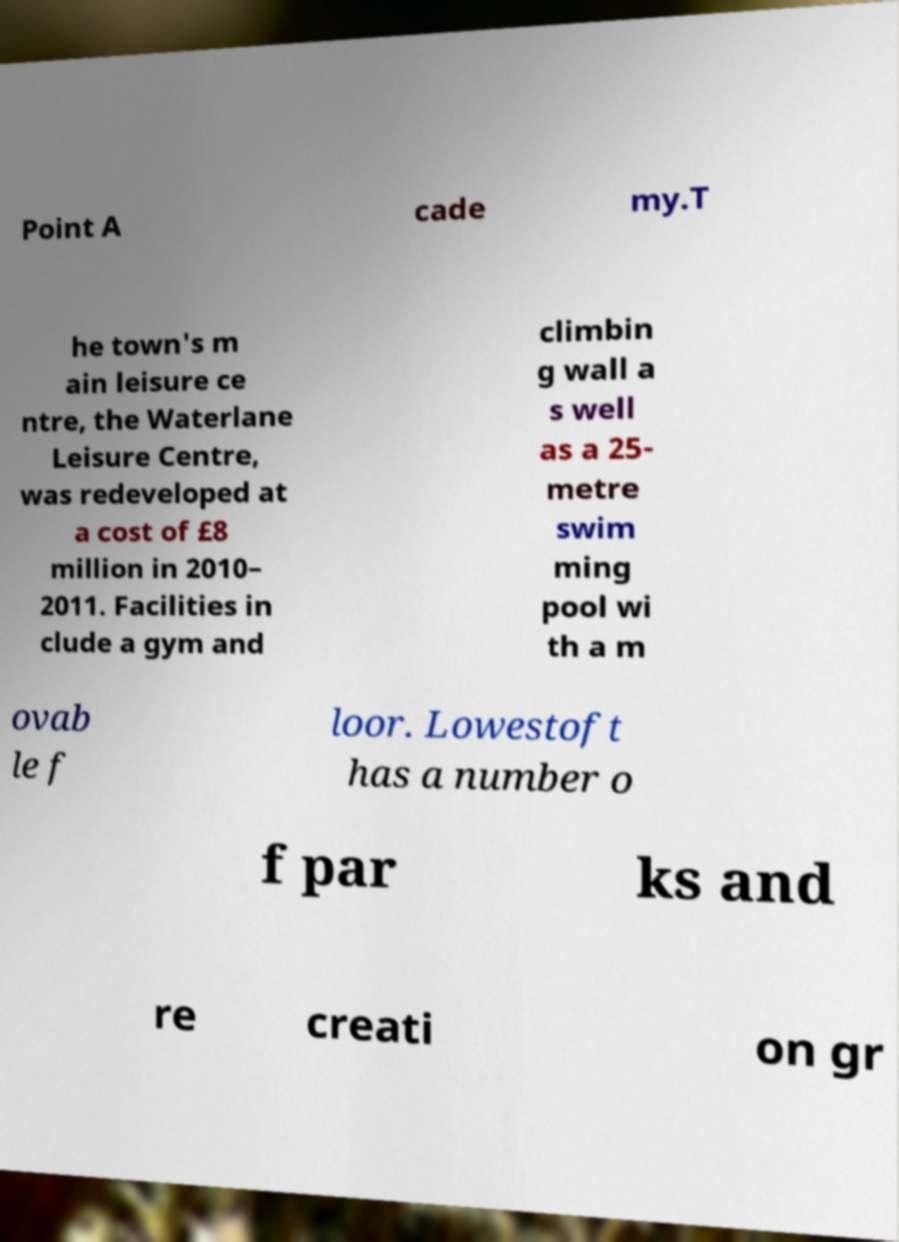For documentation purposes, I need the text within this image transcribed. Could you provide that? Point A cade my.T he town's m ain leisure ce ntre, the Waterlane Leisure Centre, was redeveloped at a cost of £8 million in 2010– 2011. Facilities in clude a gym and climbin g wall a s well as a 25- metre swim ming pool wi th a m ovab le f loor. Lowestoft has a number o f par ks and re creati on gr 